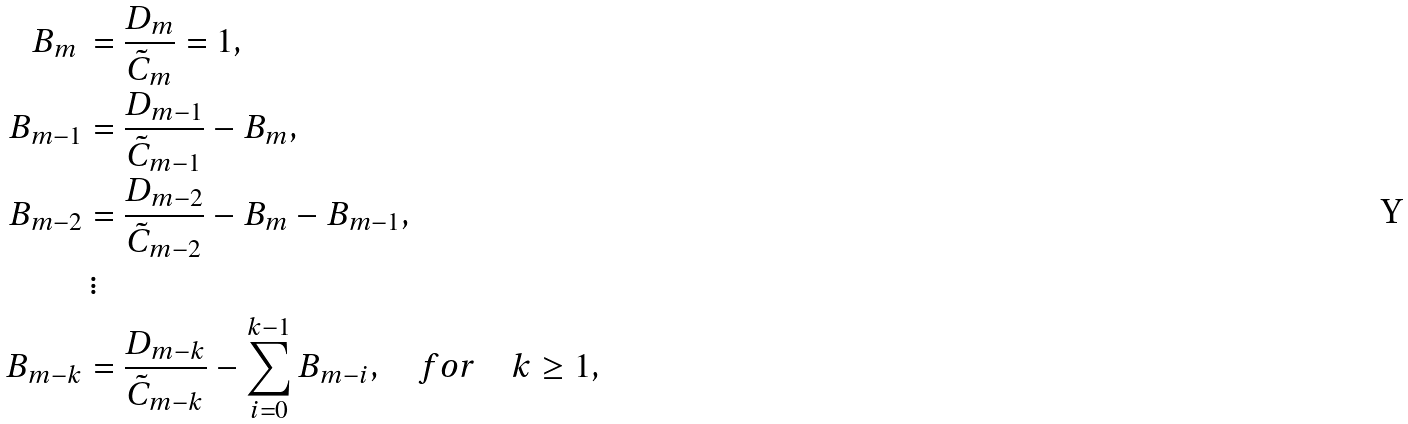<formula> <loc_0><loc_0><loc_500><loc_500>B _ { m } \, & = \frac { D _ { m } } { \tilde { C } _ { m } } = 1 , \\ B _ { m - 1 } & = \frac { D _ { m - 1 } } { \tilde { C } _ { m - 1 } } - B _ { m } , \\ B _ { m - 2 } & = \frac { D _ { m - 2 } } { \tilde { C } _ { m - 2 } } - B _ { m } - B _ { m - 1 } , \\ & \, \vdots \\ B _ { m - k } & = \frac { D _ { m - k } } { \tilde { C } _ { m - k } } - \sum _ { i = 0 } ^ { k - 1 } B _ { m - i } , \quad f o r \quad k \geq 1 ,</formula> 